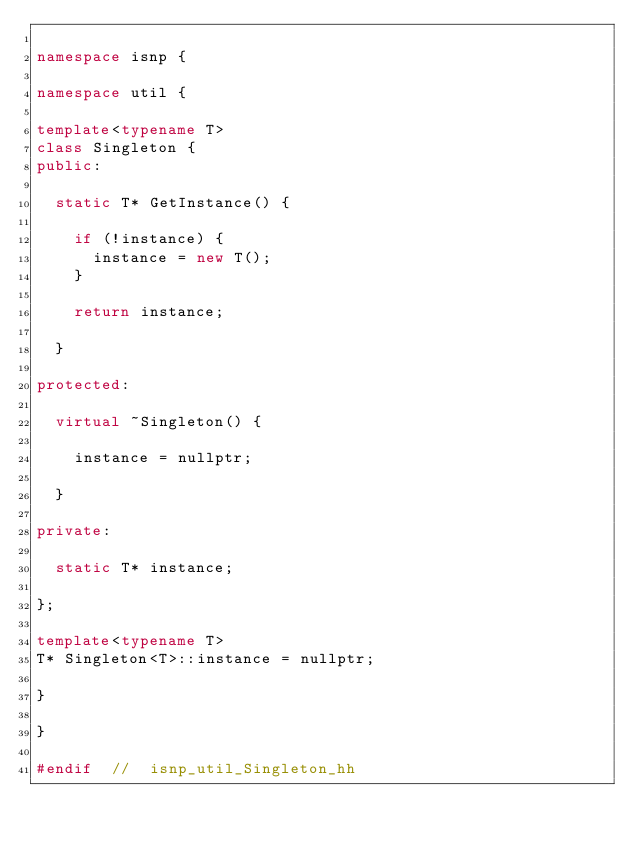Convert code to text. <code><loc_0><loc_0><loc_500><loc_500><_C++_>
namespace isnp {

namespace util {

template<typename T>
class Singleton {
public:

	static T* GetInstance() {

		if (!instance) {
			instance = new T();
		}

		return instance;

	}

protected:

	virtual ~Singleton() {

		instance = nullptr;

	}

private:

	static T* instance;

};

template<typename T>
T* Singleton<T>::instance = nullptr;

}

}

#endif	//	isnp_util_Singleton_hh
</code> 